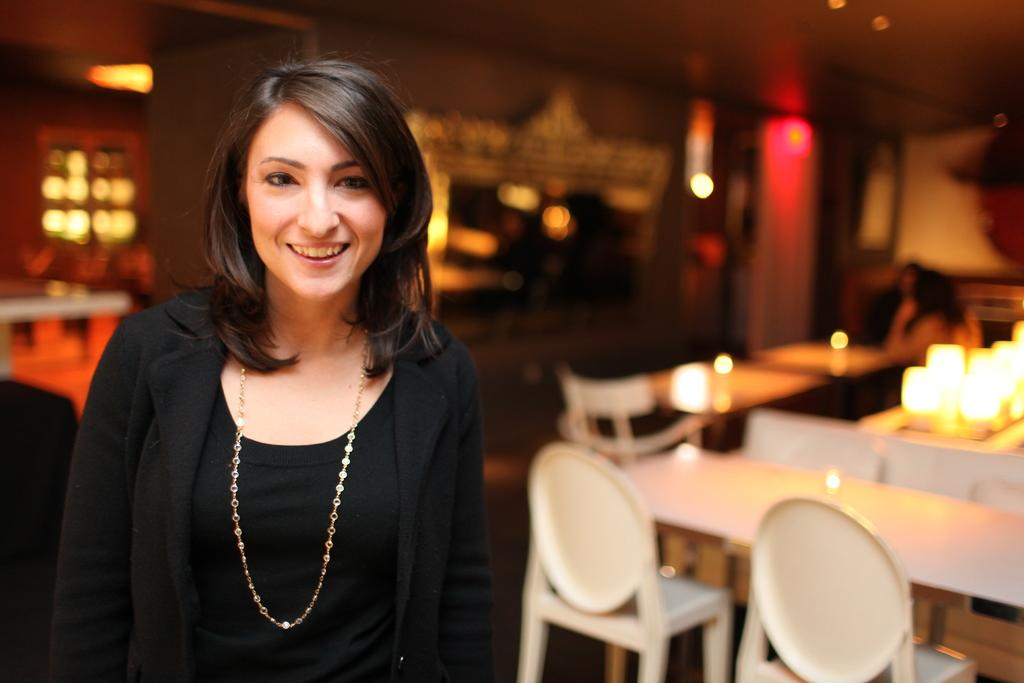What is the primary subject of the image? There is a woman standing in the image. How is the woman's expression in the image? The woman has a smile on her face. What type of furniture can be seen in the background of the image? There are chairs and tables in the background of the image. How many letters are being delivered by the lumber in the image? There is no lumber or letters present in the image. What is the profit margin of the woman in the image? There is no information about profit margins in the image, as it focuses on the woman's expression and the presence of furniture in the background. 